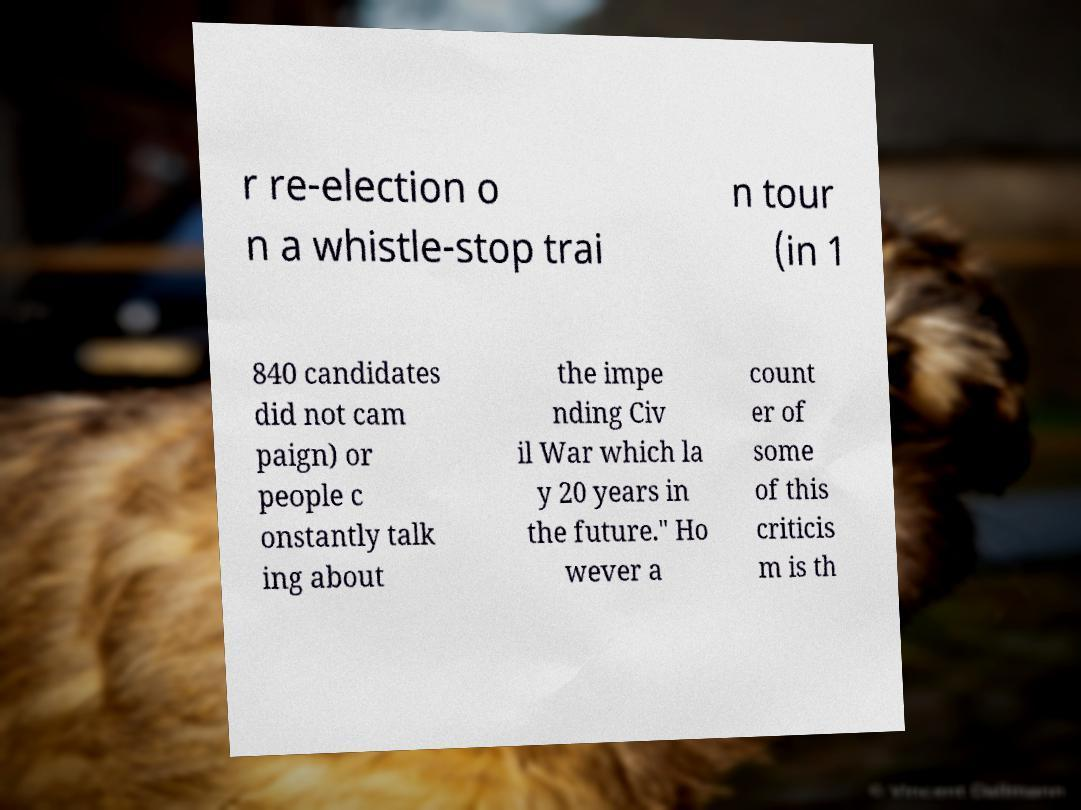Can you read and provide the text displayed in the image?This photo seems to have some interesting text. Can you extract and type it out for me? r re-election o n a whistle-stop trai n tour (in 1 840 candidates did not cam paign) or people c onstantly talk ing about the impe nding Civ il War which la y 20 years in the future." Ho wever a count er of some of this criticis m is th 